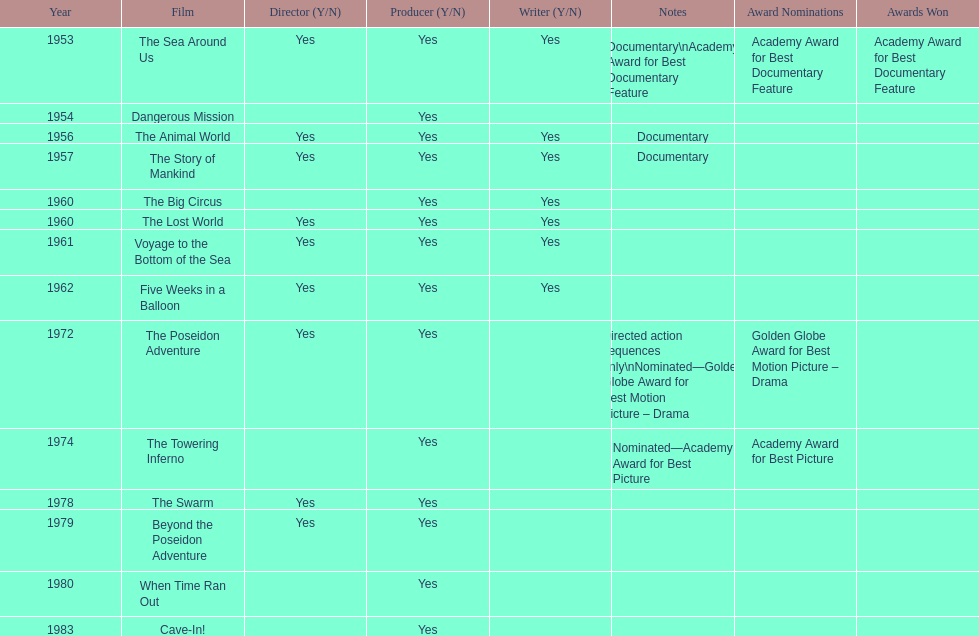Would you mind parsing the complete table? {'header': ['Year', 'Film', 'Director (Y/N)', 'Producer (Y/N)', 'Writer (Y/N)', 'Notes', 'Award Nominations', 'Awards Won'], 'rows': [['1953', 'The Sea Around Us', 'Yes', 'Yes', 'Yes', 'Documentary\\nAcademy Award for Best Documentary Feature', 'Academy Award for Best Documentary Feature', 'Academy Award for Best Documentary Feature'], ['1954', 'Dangerous Mission', '', 'Yes', '', '', '', ''], ['1956', 'The Animal World', 'Yes', 'Yes', 'Yes', 'Documentary', '', ''], ['1957', 'The Story of Mankind', 'Yes', 'Yes', 'Yes', 'Documentary', '', ''], ['1960', 'The Big Circus', '', 'Yes', 'Yes', '', '', ''], ['1960', 'The Lost World', 'Yes', 'Yes', 'Yes', '', '', ''], ['1961', 'Voyage to the Bottom of the Sea', 'Yes', 'Yes', 'Yes', '', '', ''], ['1962', 'Five Weeks in a Balloon', 'Yes', 'Yes', 'Yes', '', '', ''], ['1972', 'The Poseidon Adventure', 'Yes', 'Yes', '', 'Directed action sequences only\\nNominated—Golden Globe Award for Best Motion Picture – Drama', 'Golden Globe Award for Best Motion Picture – Drama', ''], ['1974', 'The Towering Inferno', '', 'Yes', '', 'Nominated—Academy Award for Best Picture', 'Academy Award for Best Picture', ''], ['1978', 'The Swarm', 'Yes', 'Yes', '', '', '', ''], ['1979', 'Beyond the Poseidon Adventure', 'Yes', 'Yes', '', '', '', ''], ['1980', 'When Time Ran Out', '', 'Yes', '', '', '', ''], ['1983', 'Cave-In!', '', 'Yes', '', '', '', '']]} How many films did irwin allen direct, produce and write? 6. 